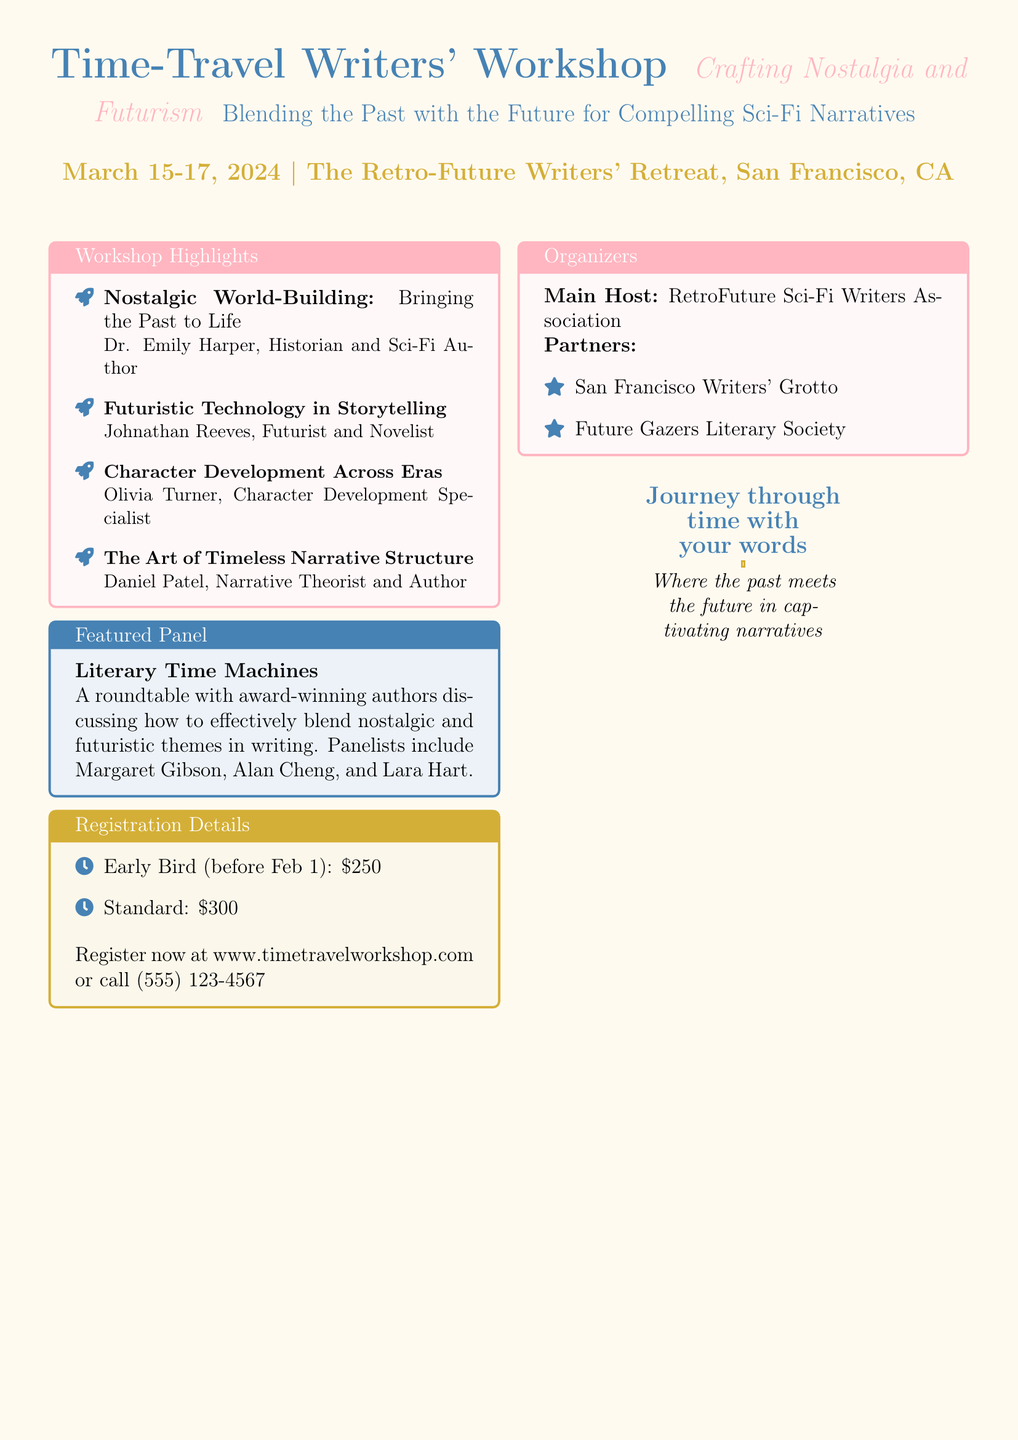What are the workshop dates? The workshop dates are provided in the document under the main event details section.
Answer: March 15-17, 2024 Who is presenting the session on Nostalgic World-Building? Each highlight in the document includes the presenter name along with their respective topic.
Answer: Dr. Emily Harper What is the registration fee for the Early Bird option? The registration details section lists the fees for different timings, including the Early Bird option.
Answer: $250 What is the title of the featured panel? The panel title is explicitly mentioned within the featured panel box of the document.
Answer: Literary Time Machines Which organization is the main host of the workshop? The organizing details provided in the document specify the main host organization.
Answer: RetroFuture Sci-Fi Writers Association What type of narrative structure will be discussed in the workshop? The workshop highlights detail the topics being discussed, including this specific one.
Answer: Timeless Narrative Structure How can participants register for the workshop? Registration methods are detailed in the registration section, outlining how to sign up.
Answer: www.timetravelworkshop.com or call (555) 123-4567 What theme do participants explore in their narratives? The overarching theme of the workshop is highlighted at the top of the flyer.
Answer: Blending the Past with the Future 